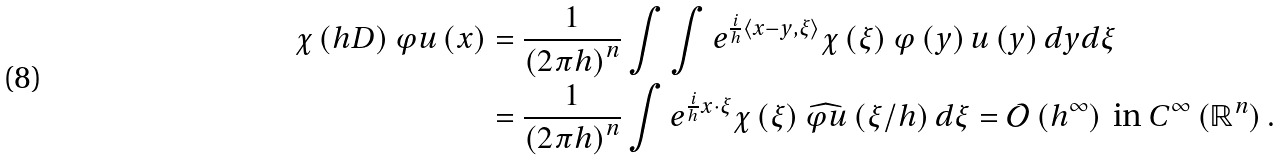Convert formula to latex. <formula><loc_0><loc_0><loc_500><loc_500>\chi \left ( h D \right ) \varphi u \left ( x \right ) & = \frac { 1 } { \left ( 2 \pi h \right ) ^ { n } } \int \int e ^ { \frac { i } { h } \left \langle x - y , \xi \right \rangle } \chi \left ( \xi \right ) \varphi \left ( y \right ) u \left ( y \right ) d y d \xi \\ & = \frac { 1 } { \left ( 2 \pi h \right ) ^ { n } } \int e ^ { \frac { i } { h } x \cdot \xi } \chi \left ( \xi \right ) \widehat { \varphi u } \left ( \xi / h \right ) d \xi = \mathcal { O } \left ( h ^ { \infty } \right ) \text { in } C ^ { \infty } \left ( \mathbb { R } ^ { n } \right ) .</formula> 